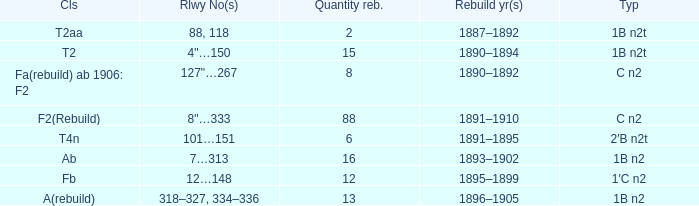What is the total of quantity rebuilt if the type is 1B N2T and the railway number is 88, 118? 1.0. 